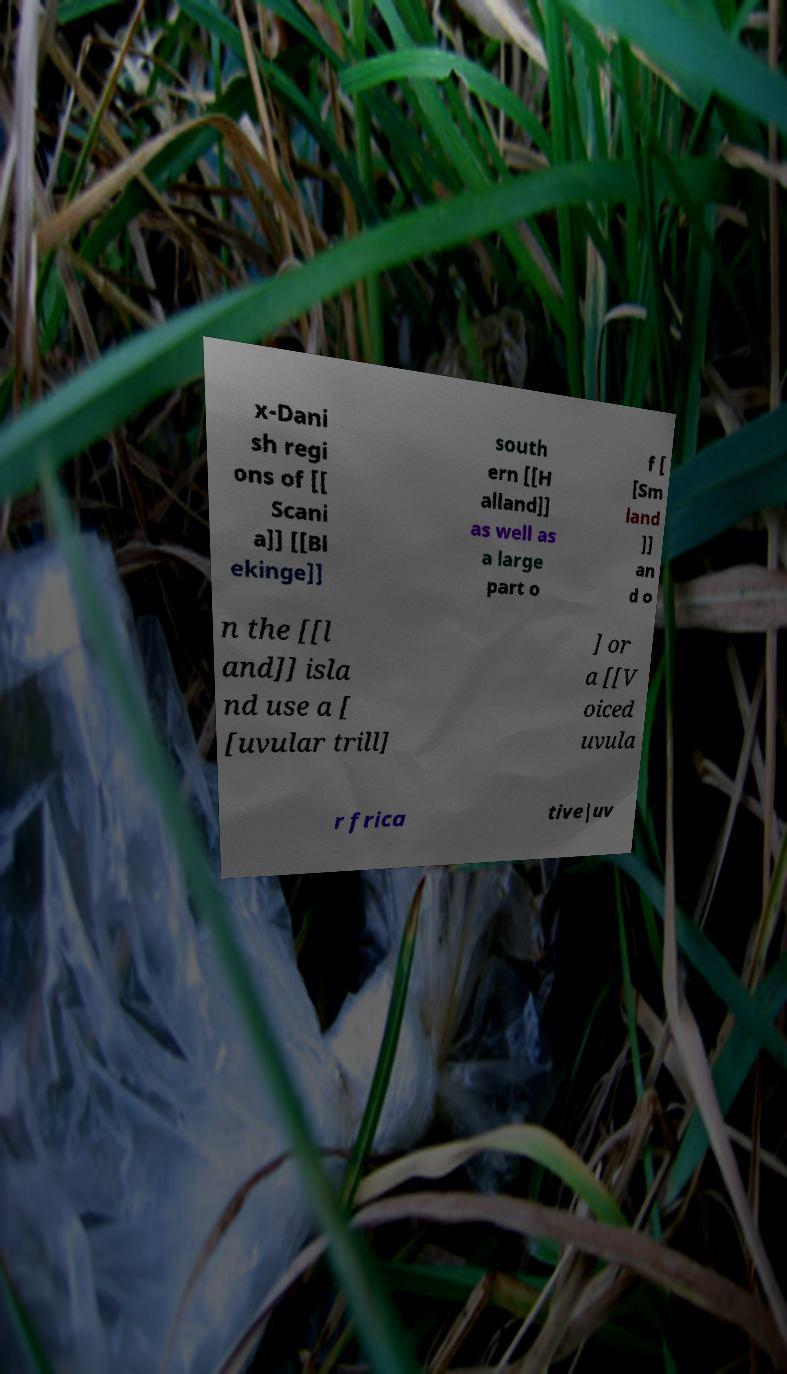Please read and relay the text visible in this image. What does it say? x-Dani sh regi ons of [[ Scani a]] [[Bl ekinge]] south ern [[H alland]] as well as a large part o f [ [Sm land ]] an d o n the [[l and]] isla nd use a [ [uvular trill] ] or a [[V oiced uvula r frica tive|uv 